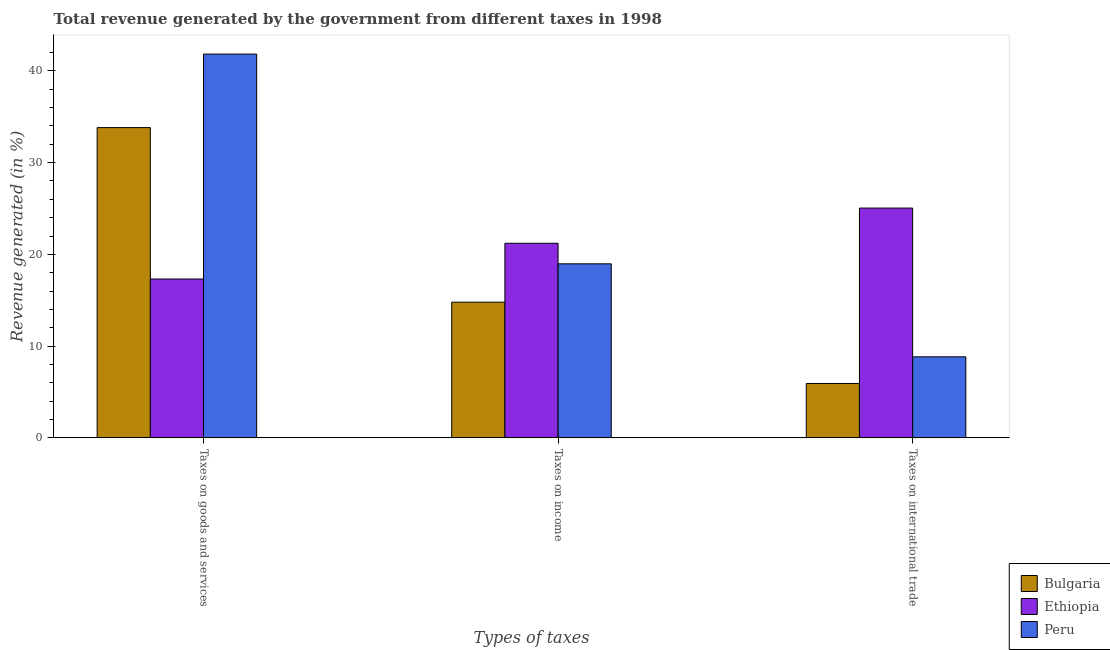How many bars are there on the 1st tick from the right?
Offer a terse response. 3. What is the label of the 1st group of bars from the left?
Your answer should be very brief. Taxes on goods and services. What is the percentage of revenue generated by taxes on goods and services in Peru?
Give a very brief answer. 41.84. Across all countries, what is the maximum percentage of revenue generated by tax on international trade?
Ensure brevity in your answer.  25.05. Across all countries, what is the minimum percentage of revenue generated by taxes on income?
Your response must be concise. 14.79. In which country was the percentage of revenue generated by taxes on goods and services maximum?
Your answer should be compact. Peru. What is the total percentage of revenue generated by taxes on income in the graph?
Ensure brevity in your answer.  54.97. What is the difference between the percentage of revenue generated by taxes on goods and services in Peru and that in Ethiopia?
Your answer should be very brief. 24.52. What is the difference between the percentage of revenue generated by taxes on income in Peru and the percentage of revenue generated by taxes on goods and services in Bulgaria?
Your response must be concise. -14.85. What is the average percentage of revenue generated by tax on international trade per country?
Ensure brevity in your answer.  13.27. What is the difference between the percentage of revenue generated by taxes on goods and services and percentage of revenue generated by tax on international trade in Bulgaria?
Make the answer very short. 27.89. What is the ratio of the percentage of revenue generated by taxes on income in Ethiopia to that in Bulgaria?
Offer a very short reply. 1.43. Is the percentage of revenue generated by taxes on income in Peru less than that in Ethiopia?
Provide a short and direct response. Yes. Is the difference between the percentage of revenue generated by taxes on income in Bulgaria and Ethiopia greater than the difference between the percentage of revenue generated by taxes on goods and services in Bulgaria and Ethiopia?
Provide a short and direct response. No. What is the difference between the highest and the second highest percentage of revenue generated by taxes on income?
Provide a short and direct response. 2.24. What is the difference between the highest and the lowest percentage of revenue generated by taxes on income?
Give a very brief answer. 6.42. In how many countries, is the percentage of revenue generated by taxes on goods and services greater than the average percentage of revenue generated by taxes on goods and services taken over all countries?
Your answer should be very brief. 2. Is the sum of the percentage of revenue generated by taxes on income in Bulgaria and Peru greater than the maximum percentage of revenue generated by tax on international trade across all countries?
Provide a succinct answer. Yes. What does the 1st bar from the left in Taxes on international trade represents?
Make the answer very short. Bulgaria. Are all the bars in the graph horizontal?
Offer a very short reply. No. How many countries are there in the graph?
Provide a succinct answer. 3. What is the difference between two consecutive major ticks on the Y-axis?
Your answer should be very brief. 10. Does the graph contain any zero values?
Keep it short and to the point. No. How many legend labels are there?
Offer a very short reply. 3. How are the legend labels stacked?
Offer a very short reply. Vertical. What is the title of the graph?
Give a very brief answer. Total revenue generated by the government from different taxes in 1998. What is the label or title of the X-axis?
Make the answer very short. Types of taxes. What is the label or title of the Y-axis?
Provide a short and direct response. Revenue generated (in %). What is the Revenue generated (in %) of Bulgaria in Taxes on goods and services?
Your answer should be compact. 33.82. What is the Revenue generated (in %) of Ethiopia in Taxes on goods and services?
Provide a succinct answer. 17.32. What is the Revenue generated (in %) of Peru in Taxes on goods and services?
Your answer should be compact. 41.84. What is the Revenue generated (in %) of Bulgaria in Taxes on income?
Ensure brevity in your answer.  14.79. What is the Revenue generated (in %) in Ethiopia in Taxes on income?
Offer a terse response. 21.21. What is the Revenue generated (in %) in Peru in Taxes on income?
Give a very brief answer. 18.97. What is the Revenue generated (in %) in Bulgaria in Taxes on international trade?
Your answer should be very brief. 5.93. What is the Revenue generated (in %) of Ethiopia in Taxes on international trade?
Provide a short and direct response. 25.05. What is the Revenue generated (in %) in Peru in Taxes on international trade?
Keep it short and to the point. 8.83. Across all Types of taxes, what is the maximum Revenue generated (in %) of Bulgaria?
Provide a succinct answer. 33.82. Across all Types of taxes, what is the maximum Revenue generated (in %) in Ethiopia?
Ensure brevity in your answer.  25.05. Across all Types of taxes, what is the maximum Revenue generated (in %) in Peru?
Offer a very short reply. 41.84. Across all Types of taxes, what is the minimum Revenue generated (in %) of Bulgaria?
Provide a short and direct response. 5.93. Across all Types of taxes, what is the minimum Revenue generated (in %) of Ethiopia?
Keep it short and to the point. 17.32. Across all Types of taxes, what is the minimum Revenue generated (in %) in Peru?
Offer a terse response. 8.83. What is the total Revenue generated (in %) in Bulgaria in the graph?
Ensure brevity in your answer.  54.54. What is the total Revenue generated (in %) in Ethiopia in the graph?
Provide a short and direct response. 63.58. What is the total Revenue generated (in %) of Peru in the graph?
Provide a short and direct response. 69.64. What is the difference between the Revenue generated (in %) of Bulgaria in Taxes on goods and services and that in Taxes on income?
Ensure brevity in your answer.  19.03. What is the difference between the Revenue generated (in %) of Ethiopia in Taxes on goods and services and that in Taxes on income?
Your response must be concise. -3.9. What is the difference between the Revenue generated (in %) of Peru in Taxes on goods and services and that in Taxes on income?
Your response must be concise. 22.86. What is the difference between the Revenue generated (in %) of Bulgaria in Taxes on goods and services and that in Taxes on international trade?
Provide a succinct answer. 27.89. What is the difference between the Revenue generated (in %) of Ethiopia in Taxes on goods and services and that in Taxes on international trade?
Provide a short and direct response. -7.74. What is the difference between the Revenue generated (in %) in Peru in Taxes on goods and services and that in Taxes on international trade?
Offer a terse response. 33. What is the difference between the Revenue generated (in %) in Bulgaria in Taxes on income and that in Taxes on international trade?
Keep it short and to the point. 8.86. What is the difference between the Revenue generated (in %) in Ethiopia in Taxes on income and that in Taxes on international trade?
Keep it short and to the point. -3.84. What is the difference between the Revenue generated (in %) in Peru in Taxes on income and that in Taxes on international trade?
Make the answer very short. 10.14. What is the difference between the Revenue generated (in %) in Bulgaria in Taxes on goods and services and the Revenue generated (in %) in Ethiopia in Taxes on income?
Give a very brief answer. 12.61. What is the difference between the Revenue generated (in %) in Bulgaria in Taxes on goods and services and the Revenue generated (in %) in Peru in Taxes on income?
Provide a succinct answer. 14.85. What is the difference between the Revenue generated (in %) in Ethiopia in Taxes on goods and services and the Revenue generated (in %) in Peru in Taxes on income?
Your answer should be very brief. -1.66. What is the difference between the Revenue generated (in %) of Bulgaria in Taxes on goods and services and the Revenue generated (in %) of Ethiopia in Taxes on international trade?
Give a very brief answer. 8.77. What is the difference between the Revenue generated (in %) of Bulgaria in Taxes on goods and services and the Revenue generated (in %) of Peru in Taxes on international trade?
Ensure brevity in your answer.  24.99. What is the difference between the Revenue generated (in %) in Ethiopia in Taxes on goods and services and the Revenue generated (in %) in Peru in Taxes on international trade?
Make the answer very short. 8.48. What is the difference between the Revenue generated (in %) of Bulgaria in Taxes on income and the Revenue generated (in %) of Ethiopia in Taxes on international trade?
Your answer should be compact. -10.26. What is the difference between the Revenue generated (in %) in Bulgaria in Taxes on income and the Revenue generated (in %) in Peru in Taxes on international trade?
Offer a very short reply. 5.96. What is the difference between the Revenue generated (in %) of Ethiopia in Taxes on income and the Revenue generated (in %) of Peru in Taxes on international trade?
Make the answer very short. 12.38. What is the average Revenue generated (in %) of Bulgaria per Types of taxes?
Make the answer very short. 18.18. What is the average Revenue generated (in %) of Ethiopia per Types of taxes?
Ensure brevity in your answer.  21.19. What is the average Revenue generated (in %) in Peru per Types of taxes?
Offer a very short reply. 23.21. What is the difference between the Revenue generated (in %) of Bulgaria and Revenue generated (in %) of Ethiopia in Taxes on goods and services?
Offer a terse response. 16.51. What is the difference between the Revenue generated (in %) of Bulgaria and Revenue generated (in %) of Peru in Taxes on goods and services?
Provide a short and direct response. -8.02. What is the difference between the Revenue generated (in %) of Ethiopia and Revenue generated (in %) of Peru in Taxes on goods and services?
Make the answer very short. -24.52. What is the difference between the Revenue generated (in %) in Bulgaria and Revenue generated (in %) in Ethiopia in Taxes on income?
Offer a terse response. -6.42. What is the difference between the Revenue generated (in %) in Bulgaria and Revenue generated (in %) in Peru in Taxes on income?
Give a very brief answer. -4.18. What is the difference between the Revenue generated (in %) of Ethiopia and Revenue generated (in %) of Peru in Taxes on income?
Your response must be concise. 2.24. What is the difference between the Revenue generated (in %) of Bulgaria and Revenue generated (in %) of Ethiopia in Taxes on international trade?
Give a very brief answer. -19.12. What is the difference between the Revenue generated (in %) in Bulgaria and Revenue generated (in %) in Peru in Taxes on international trade?
Your answer should be compact. -2.9. What is the difference between the Revenue generated (in %) of Ethiopia and Revenue generated (in %) of Peru in Taxes on international trade?
Ensure brevity in your answer.  16.22. What is the ratio of the Revenue generated (in %) in Bulgaria in Taxes on goods and services to that in Taxes on income?
Offer a very short reply. 2.29. What is the ratio of the Revenue generated (in %) in Ethiopia in Taxes on goods and services to that in Taxes on income?
Provide a short and direct response. 0.82. What is the ratio of the Revenue generated (in %) in Peru in Taxes on goods and services to that in Taxes on income?
Provide a succinct answer. 2.21. What is the ratio of the Revenue generated (in %) in Bulgaria in Taxes on goods and services to that in Taxes on international trade?
Keep it short and to the point. 5.7. What is the ratio of the Revenue generated (in %) of Ethiopia in Taxes on goods and services to that in Taxes on international trade?
Ensure brevity in your answer.  0.69. What is the ratio of the Revenue generated (in %) of Peru in Taxes on goods and services to that in Taxes on international trade?
Your answer should be compact. 4.74. What is the ratio of the Revenue generated (in %) in Bulgaria in Taxes on income to that in Taxes on international trade?
Your response must be concise. 2.49. What is the ratio of the Revenue generated (in %) of Ethiopia in Taxes on income to that in Taxes on international trade?
Offer a terse response. 0.85. What is the ratio of the Revenue generated (in %) in Peru in Taxes on income to that in Taxes on international trade?
Provide a succinct answer. 2.15. What is the difference between the highest and the second highest Revenue generated (in %) in Bulgaria?
Provide a short and direct response. 19.03. What is the difference between the highest and the second highest Revenue generated (in %) in Ethiopia?
Provide a succinct answer. 3.84. What is the difference between the highest and the second highest Revenue generated (in %) of Peru?
Your response must be concise. 22.86. What is the difference between the highest and the lowest Revenue generated (in %) in Bulgaria?
Provide a succinct answer. 27.89. What is the difference between the highest and the lowest Revenue generated (in %) of Ethiopia?
Make the answer very short. 7.74. What is the difference between the highest and the lowest Revenue generated (in %) in Peru?
Offer a very short reply. 33. 